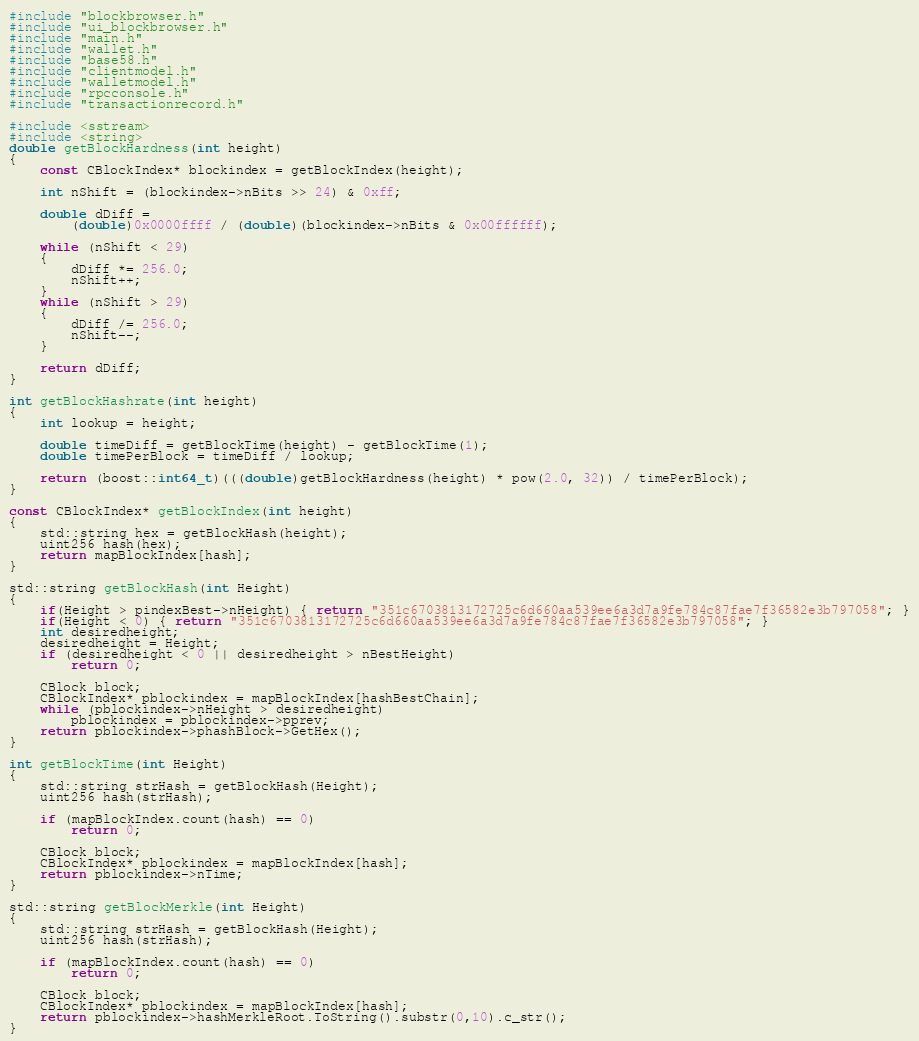Convert code to text. <code><loc_0><loc_0><loc_500><loc_500><_C++_>#include "blockbrowser.h"
#include "ui_blockbrowser.h"
#include "main.h"
#include "wallet.h"
#include "base58.h"
#include "clientmodel.h"
#include "walletmodel.h"
#include "rpcconsole.h"
#include "transactionrecord.h"

#include <sstream>
#include <string>
double getBlockHardness(int height)
{
    const CBlockIndex* blockindex = getBlockIndex(height);

    int nShift = (blockindex->nBits >> 24) & 0xff;

    double dDiff =
        (double)0x0000ffff / (double)(blockindex->nBits & 0x00ffffff);

    while (nShift < 29)
    {
        dDiff *= 256.0;
        nShift++;
    }
    while (nShift > 29)
    {
        dDiff /= 256.0;
        nShift--;
    }

    return dDiff;
}

int getBlockHashrate(int height)
{
    int lookup = height;

    double timeDiff = getBlockTime(height) - getBlockTime(1);
    double timePerBlock = timeDiff / lookup;

    return (boost::int64_t)(((double)getBlockHardness(height) * pow(2.0, 32)) / timePerBlock);
}

const CBlockIndex* getBlockIndex(int height)
{
    std::string hex = getBlockHash(height);
    uint256 hash(hex);
    return mapBlockIndex[hash];
}

std::string getBlockHash(int Height)
{
    if(Height > pindexBest->nHeight) { return "351c6703813172725c6d660aa539ee6a3d7a9fe784c87fae7f36582e3b797058"; }
    if(Height < 0) { return "351c6703813172725c6d660aa539ee6a3d7a9fe784c87fae7f36582e3b797058"; }
    int desiredheight;
    desiredheight = Height;
    if (desiredheight < 0 || desiredheight > nBestHeight)
        return 0;

    CBlock block;
    CBlockIndex* pblockindex = mapBlockIndex[hashBestChain];
    while (pblockindex->nHeight > desiredheight)
        pblockindex = pblockindex->pprev;
    return pblockindex->phashBlock->GetHex();
}

int getBlockTime(int Height)
{
    std::string strHash = getBlockHash(Height);
    uint256 hash(strHash);

    if (mapBlockIndex.count(hash) == 0)
        return 0;

    CBlock block;
    CBlockIndex* pblockindex = mapBlockIndex[hash];
    return pblockindex->nTime;
}

std::string getBlockMerkle(int Height)
{
    std::string strHash = getBlockHash(Height);
    uint256 hash(strHash);

    if (mapBlockIndex.count(hash) == 0)
        return 0;

    CBlock block;
    CBlockIndex* pblockindex = mapBlockIndex[hash];
    return pblockindex->hashMerkleRoot.ToString().substr(0,10).c_str();
}
</code> 